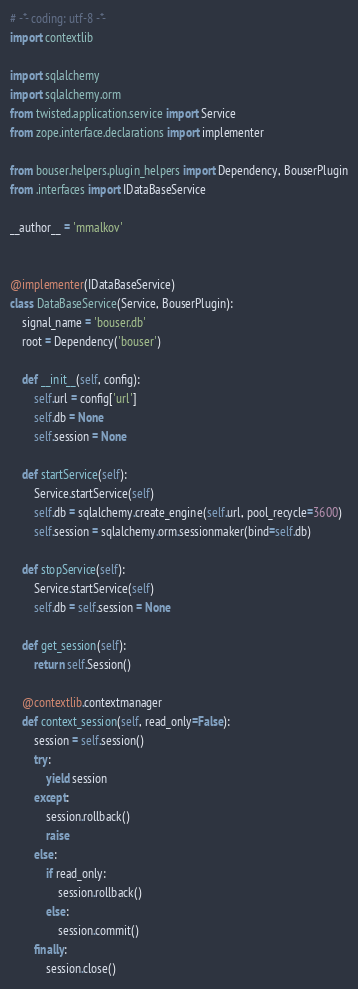Convert code to text. <code><loc_0><loc_0><loc_500><loc_500><_Python_># -*- coding: utf-8 -*-
import contextlib

import sqlalchemy
import sqlalchemy.orm
from twisted.application.service import Service
from zope.interface.declarations import implementer

from bouser.helpers.plugin_helpers import Dependency, BouserPlugin
from .interfaces import IDataBaseService

__author__ = 'mmalkov'


@implementer(IDataBaseService)
class DataBaseService(Service, BouserPlugin):
    signal_name = 'bouser.db'
    root = Dependency('bouser')

    def __init__(self, config):
        self.url = config['url']
        self.db = None
        self.session = None

    def startService(self):
        Service.startService(self)
        self.db = sqlalchemy.create_engine(self.url, pool_recycle=3600)
        self.session = sqlalchemy.orm.sessionmaker(bind=self.db)

    def stopService(self):
        Service.startService(self)
        self.db = self.session = None

    def get_session(self):
        return self.Session()

    @contextlib.contextmanager
    def context_session(self, read_only=False):
        session = self.session()
        try:
            yield session
        except:
            session.rollback()
            raise
        else:
            if read_only:
                session.rollback()
            else:
                session.commit()
        finally:
            session.close()

</code> 